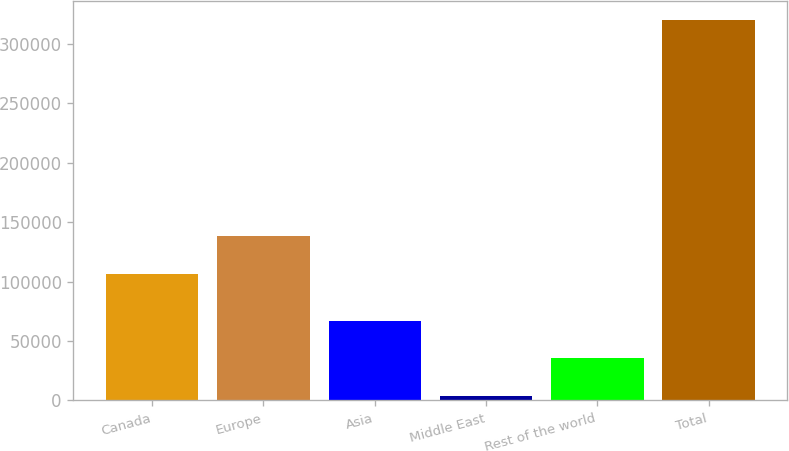<chart> <loc_0><loc_0><loc_500><loc_500><bar_chart><fcel>Canada<fcel>Europe<fcel>Asia<fcel>Middle East<fcel>Rest of the world<fcel>Total<nl><fcel>106598<fcel>138217<fcel>67062.6<fcel>3824<fcel>35443.3<fcel>320017<nl></chart> 